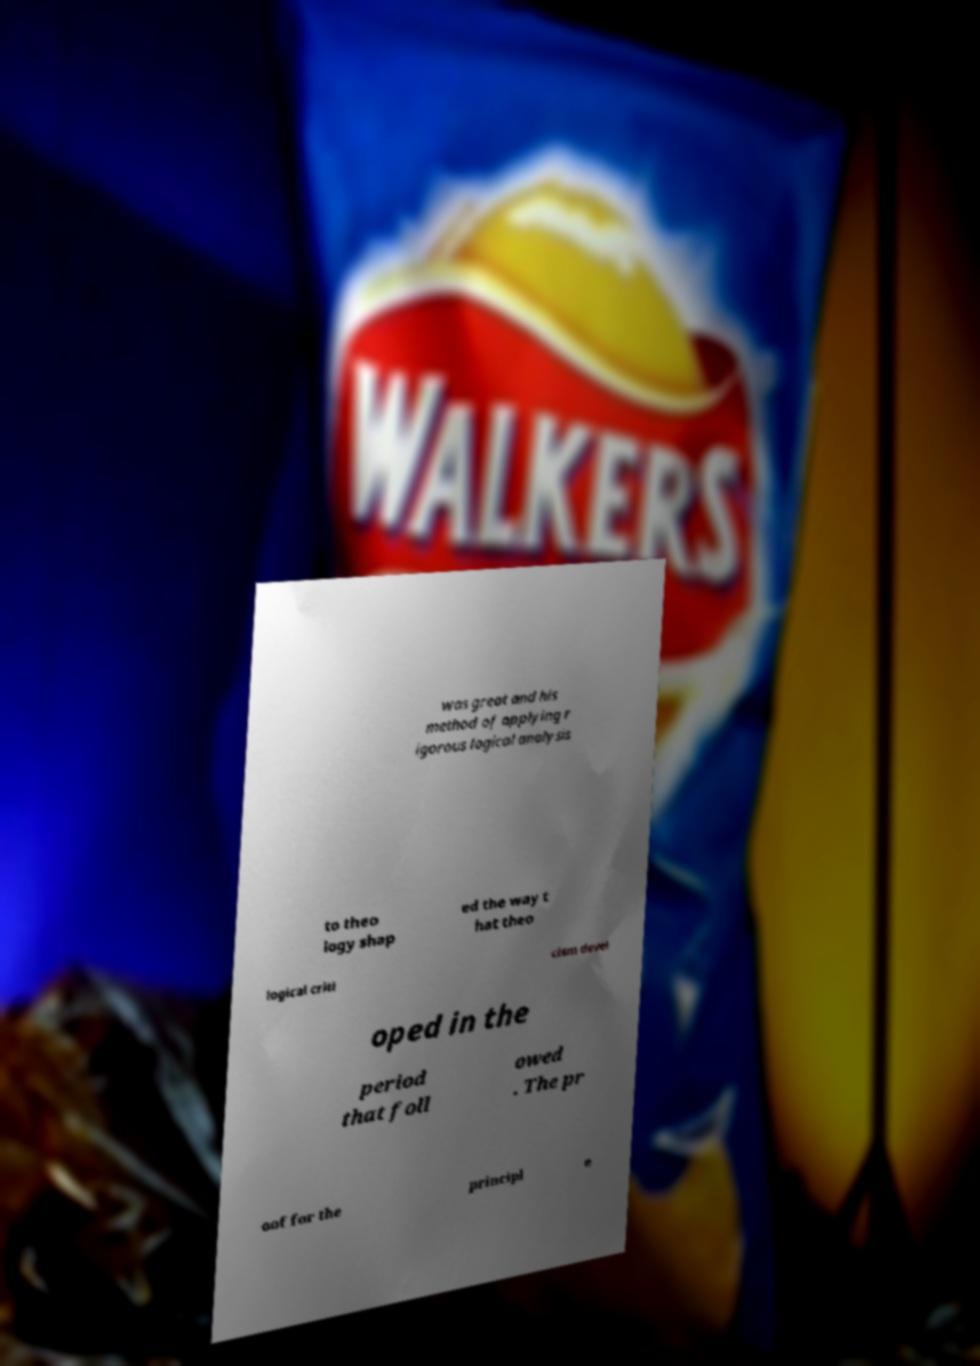Please read and relay the text visible in this image. What does it say? was great and his method of applying r igorous logical analysis to theo logy shap ed the way t hat theo logical criti cism devel oped in the period that foll owed . The pr oof for the principl e 